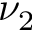<formula> <loc_0><loc_0><loc_500><loc_500>\nu _ { 2 }</formula> 